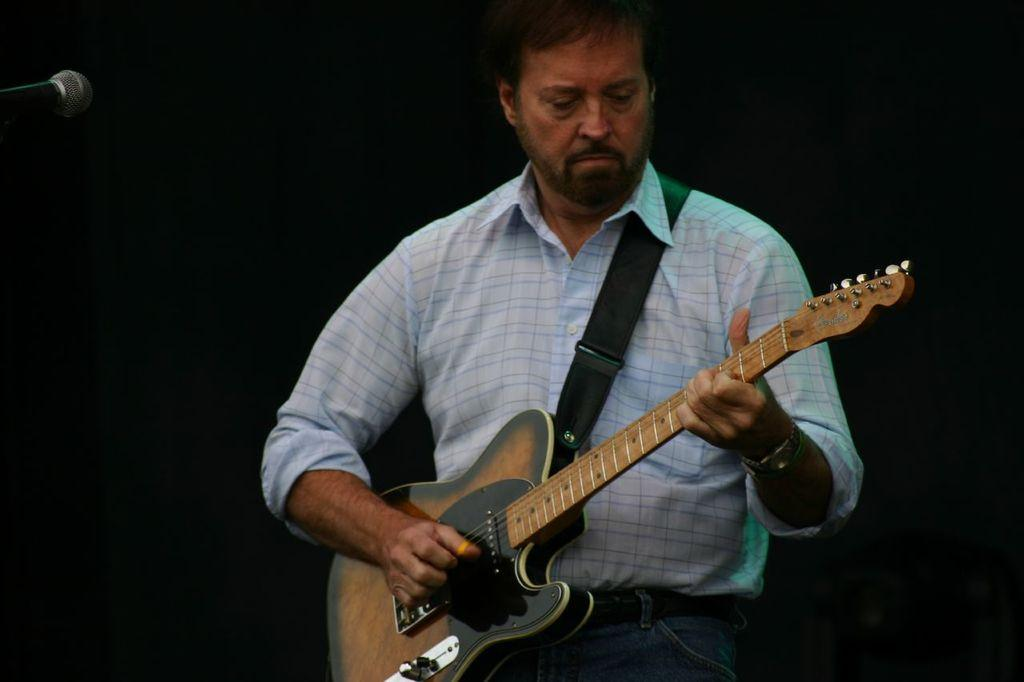What is the main subject of the image? The main subject of the image is a man. What is the man doing in the image? The man is playing a guitar. What type of peace symbol can be seen on the man's shirt in the image? There is no peace symbol visible on the man's shirt in the image. How many potatoes can be seen in the image? There are no potatoes present in the image. 